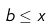Convert formula to latex. <formula><loc_0><loc_0><loc_500><loc_500>b \leq x</formula> 